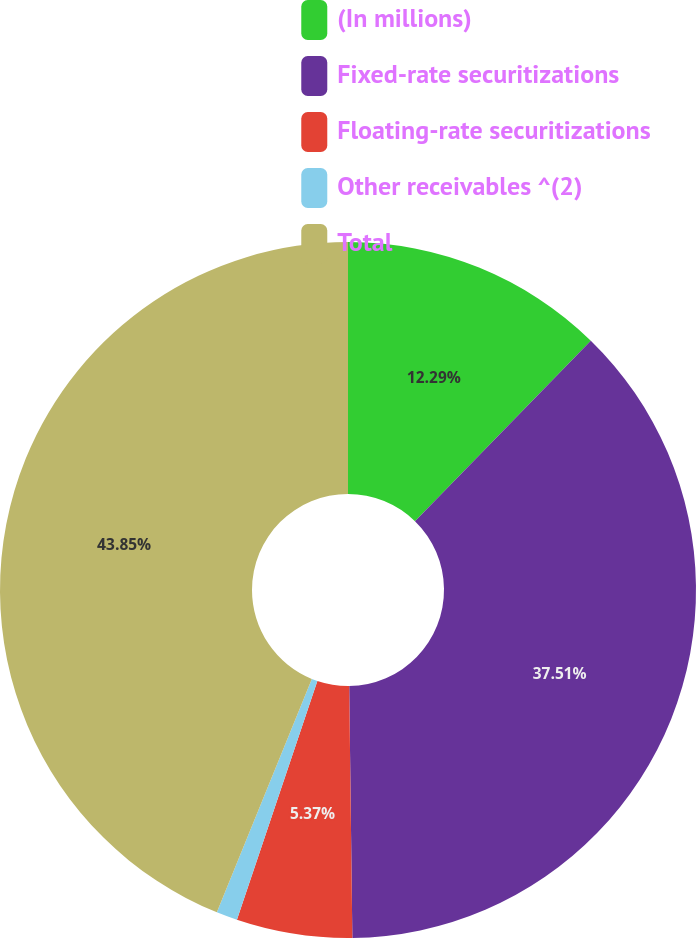Convert chart to OTSL. <chart><loc_0><loc_0><loc_500><loc_500><pie_chart><fcel>(In millions)<fcel>Fixed-rate securitizations<fcel>Floating-rate securitizations<fcel>Other receivables ^(2)<fcel>Total<nl><fcel>12.29%<fcel>37.51%<fcel>5.37%<fcel>0.98%<fcel>43.85%<nl></chart> 